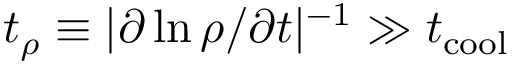Convert formula to latex. <formula><loc_0><loc_0><loc_500><loc_500>t _ { \rho } \equiv | \partial \ln \rho / \partial t | ^ { - 1 } \gg t _ { c o o l }</formula> 